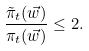Convert formula to latex. <formula><loc_0><loc_0><loc_500><loc_500>\frac { \tilde { \pi } _ { t } ( \vec { w } ) } { \pi _ { t } ( \vec { w } ) } \leq 2 .</formula> 